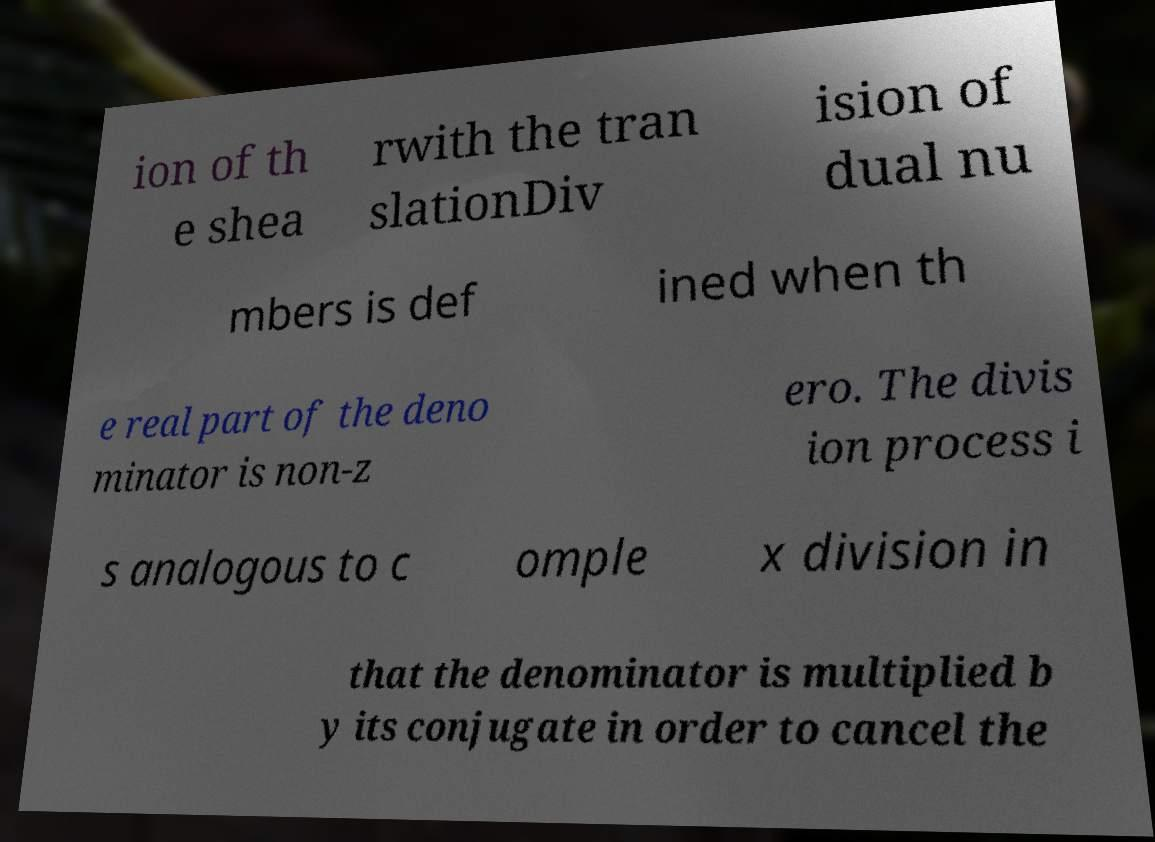I need the written content from this picture converted into text. Can you do that? ion of th e shea rwith the tran slationDiv ision of dual nu mbers is def ined when th e real part of the deno minator is non-z ero. The divis ion process i s analogous to c omple x division in that the denominator is multiplied b y its conjugate in order to cancel the 